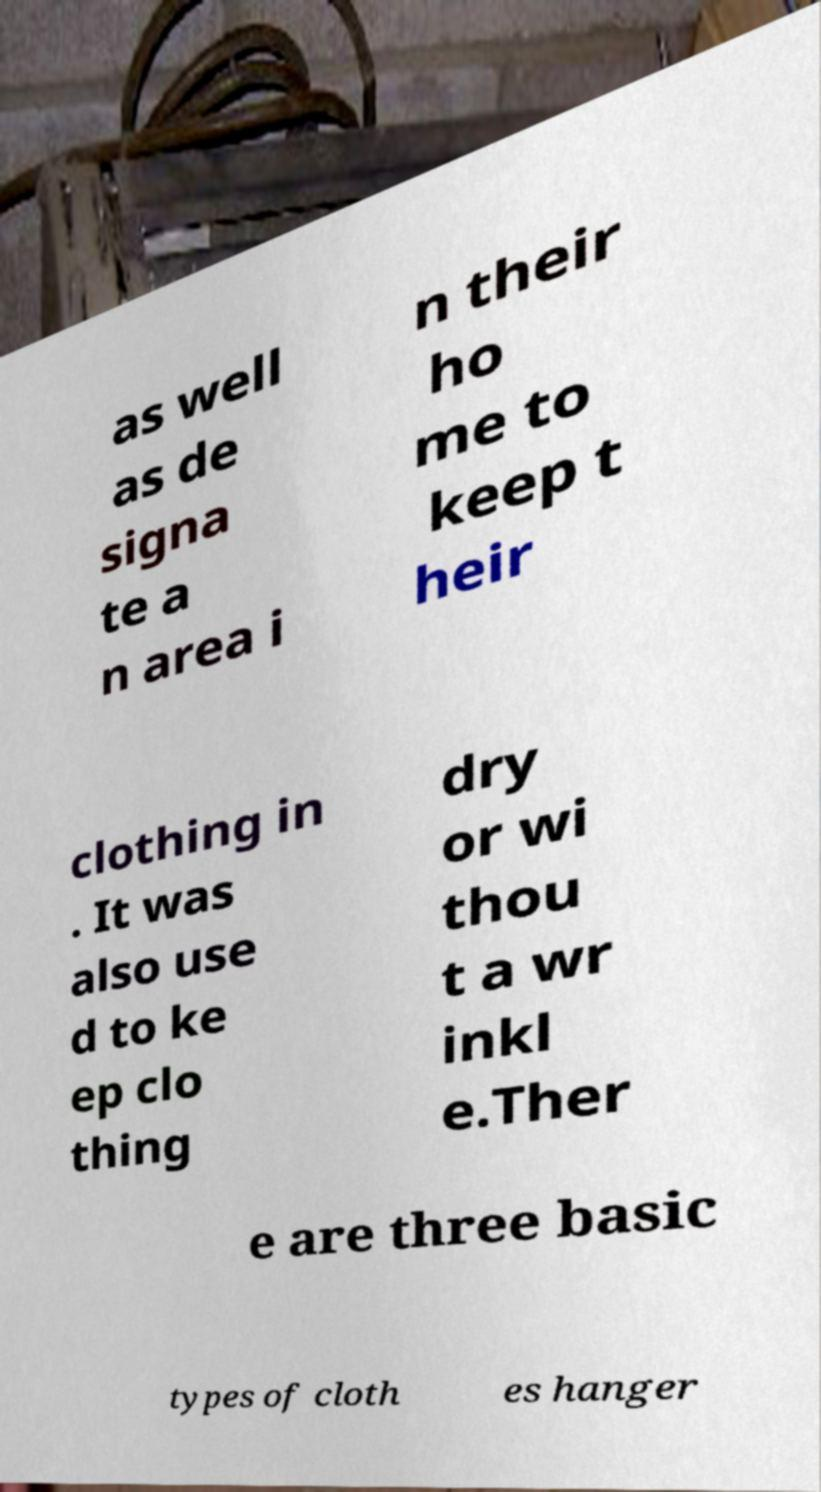Could you assist in decoding the text presented in this image and type it out clearly? as well as de signa te a n area i n their ho me to keep t heir clothing in . It was also use d to ke ep clo thing dry or wi thou t a wr inkl e.Ther e are three basic types of cloth es hanger 